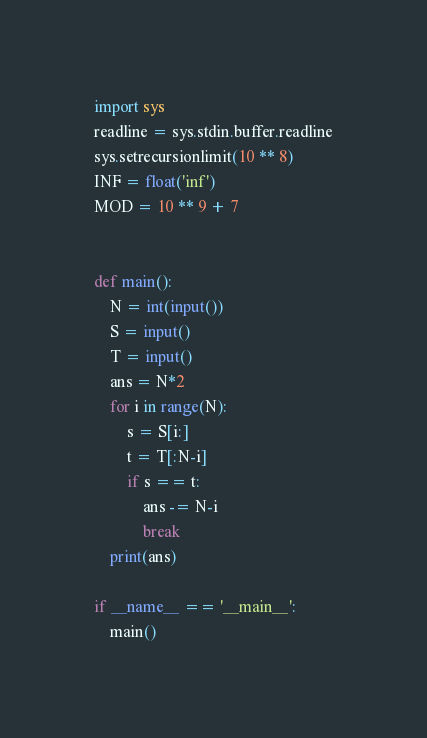Convert code to text. <code><loc_0><loc_0><loc_500><loc_500><_Python_>import sys
readline = sys.stdin.buffer.readline
sys.setrecursionlimit(10 ** 8)
INF = float('inf')
MOD = 10 ** 9 + 7


def main():
    N = int(input())
    S = input()
    T = input()
    ans = N*2
    for i in range(N):
        s = S[i:]
        t = T[:N-i]
        if s == t:
            ans -= N-i
            break
    print(ans)

if __name__ == '__main__':
    main()</code> 